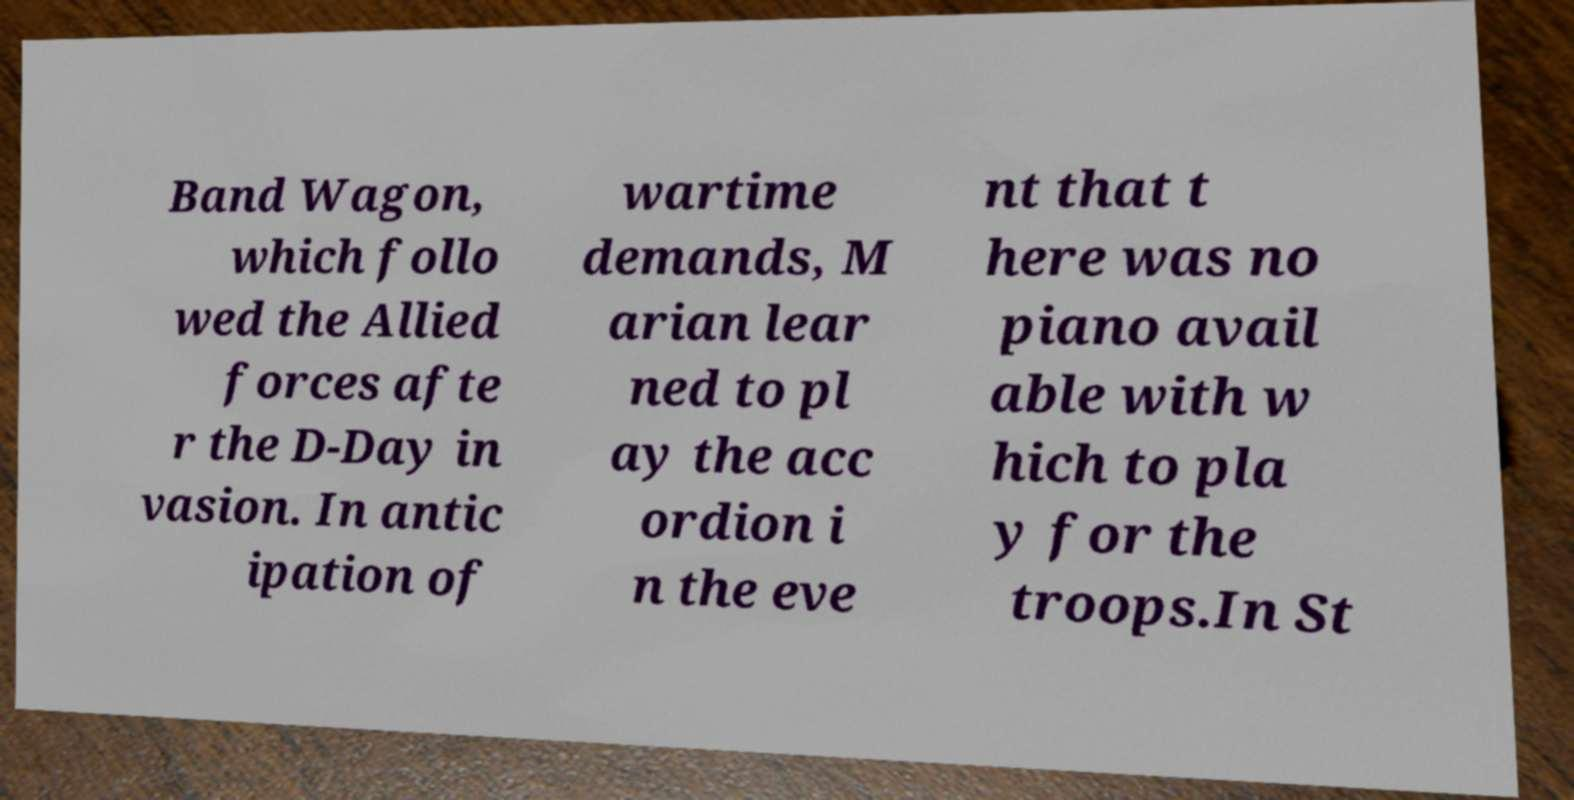There's text embedded in this image that I need extracted. Can you transcribe it verbatim? Band Wagon, which follo wed the Allied forces afte r the D-Day in vasion. In antic ipation of wartime demands, M arian lear ned to pl ay the acc ordion i n the eve nt that t here was no piano avail able with w hich to pla y for the troops.In St 